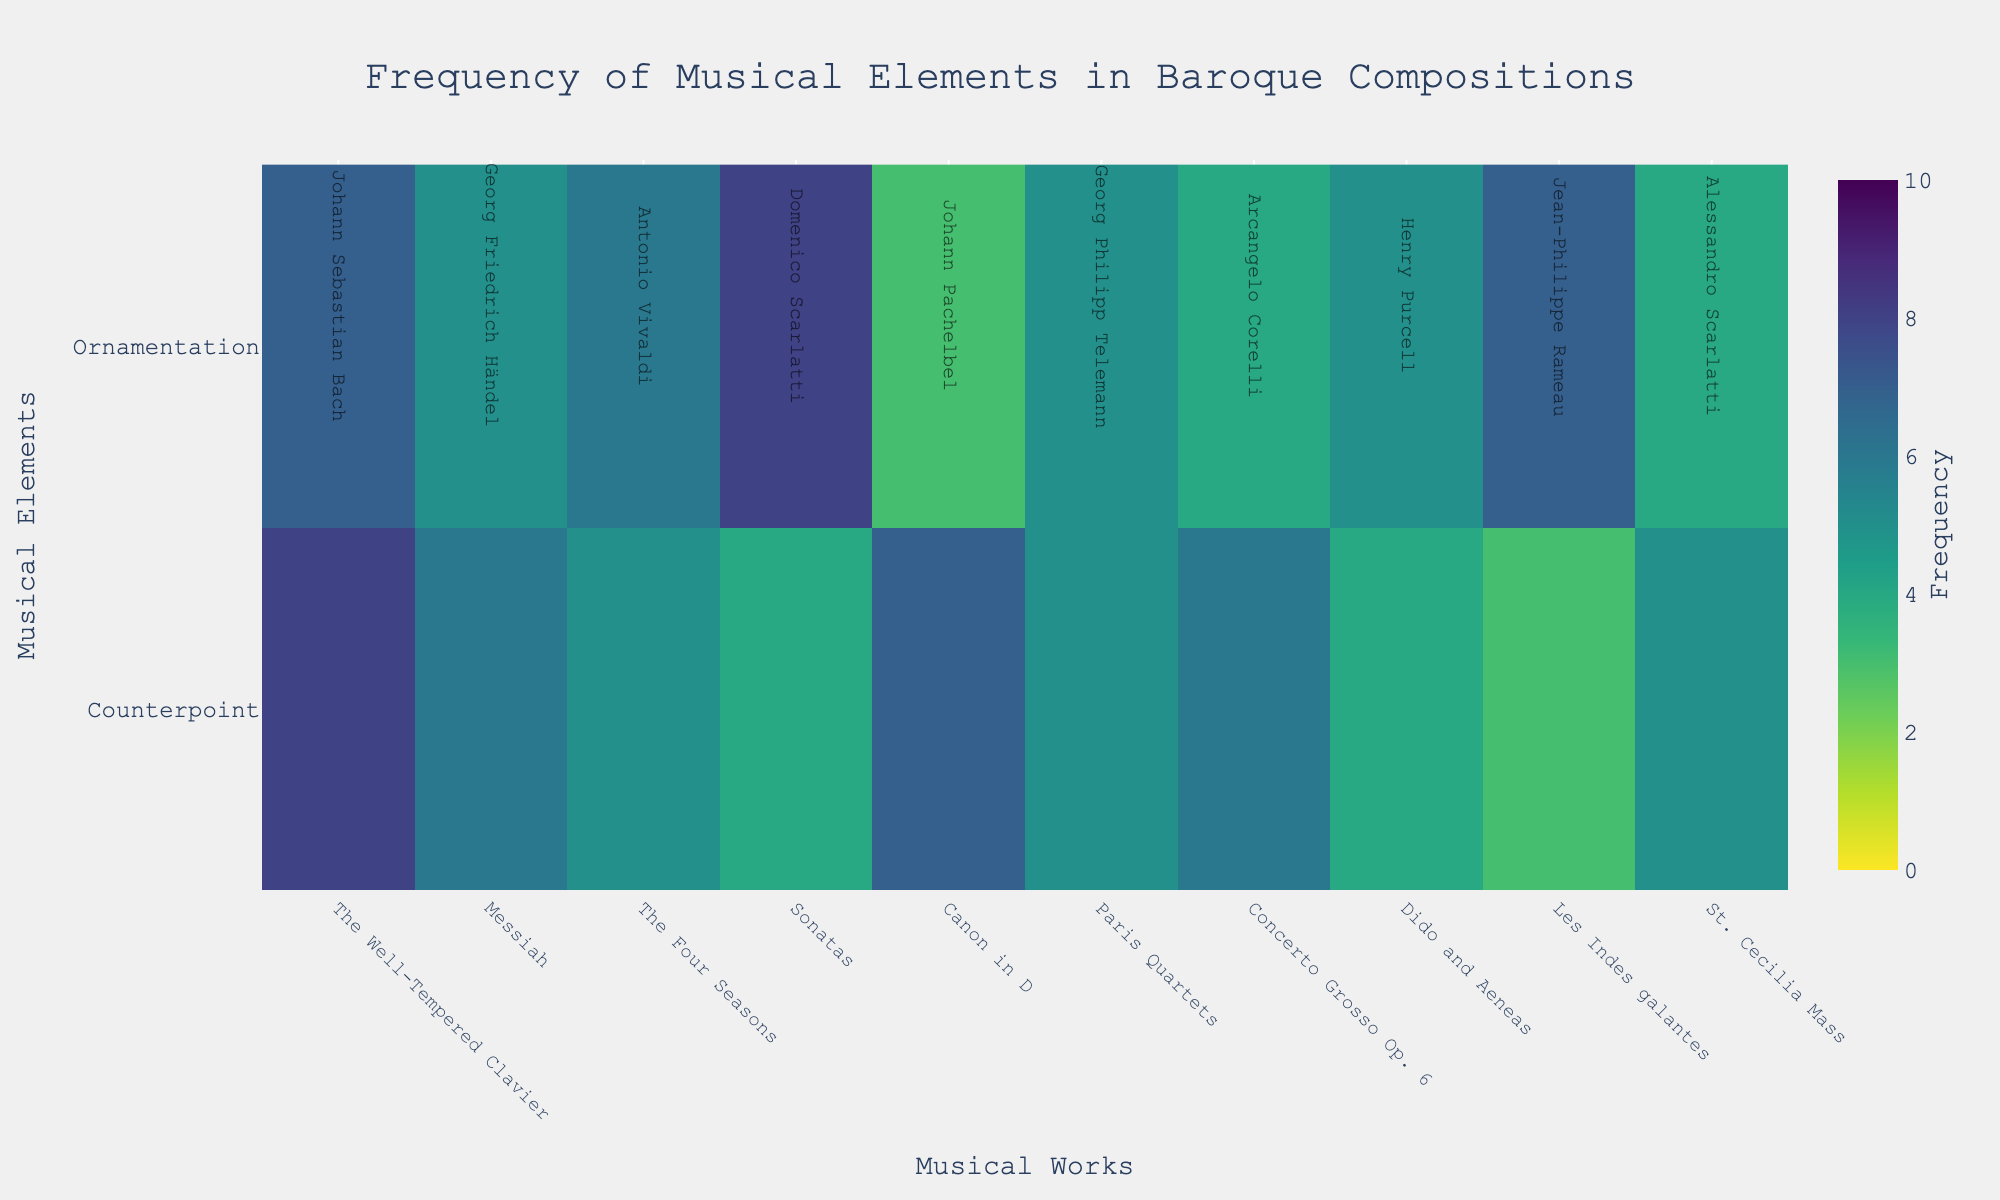what is the title of the heatmap? The title is a textual element typically displayed at the top center of the heatmap graph. In this case, it is provided in the code's layout section as 'Frequency of Musical Elements in Baroque Compositions'.
Answer: Frequency of Musical Elements in Baroque Compositions Which composer has the highest ornamentation frequency in their work? To find the composer with the highest ornamentation frequency, look at the 'Ornamentation' row and identify the highest value. Then, check the corresponding work to see who the composer is. Here, the highest value in 'Ornamentation' is 8, and it corresponds to 'Sonatas' by Domenico Scarlatti.
Answer: Domenico Scarlatti What is the average frequency of counterpoint in the works presented? Sum the counterpoint frequencies for all the works and then divide by the number of works. The counterpoint values are 8, 6, 5, 4, 7, 5, 6, 4, 3, and 5, respectively. Summing these values gives 53. There are 10 works in total, so the average is 53 / 10 = 5.3.
Answer: 5.3 Between "The Well-Tempered Clavier" and "Messiah," which has a higher frequency of ornamentation? Compare the values of 'Ornamentation' for "The Well-Tempered Clavier" and "Messiah". "The Well-Tempered Clavier" has an ornamentation value of 7, while "Messiah" has a value of 5. Thus, "The Well-Tempered Clavier" has a higher frequency of ornamentation.
Answer: The Well-Tempered Clavier Which musical work shows an equal frequency for both counterpoint and ornamentation? To find a work with equal frequency of counterpoint and ornamentation, look for corresponding values in both rows that match. 'Paris Quartets' has an equal frequency of 5 for both counterpoint and ornamentation.
Answer: Paris Quartets What is the total frequency of ornamentation across all the works? Add up all the ornamentation frequency values: 7 + 5 + 6 + 8 + 3 + 5 + 4 + 5 + 7 + 4 = 54.
Answer: 54 Which work has the lowest frequency of counterpoint? Look at the 'Counterpoint' row and identify the work with the lowest value. In this case, 'Les Indes galantes' has the lowest frequency of counterpoint, which is 3.
Answer: Les Indes galantes How does the counterpoint frequency in 'Canon in D' compare to that in 'St. Cecilia Mass'? Compare the counterpoint values for both works. 'Canon in D' has a counterpoint value of 7, and 'St. Cecilia Mass' has a counterpoint value of 5. Therefore, 'Canon in D' has a higher counterpoint frequency than 'St. Cecilia Mass'.
Answer: Canon in D Sum the frequencies of Counterpoint and Ornamentation for 'The Four Seasons'. Identify the values for 'Counterpoint' and 'Ornamentation' in 'The Four Seasons'. The values are 5 for 'Counterpoint' and 6 for 'Ornamentation'. Sum these values: 5 + 6 = 11.
Answer: 11 